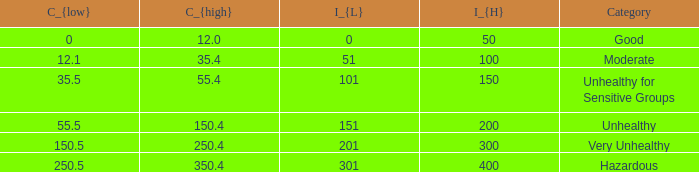In how many different categories is the value of C_{low} 35.5? 1.0. 